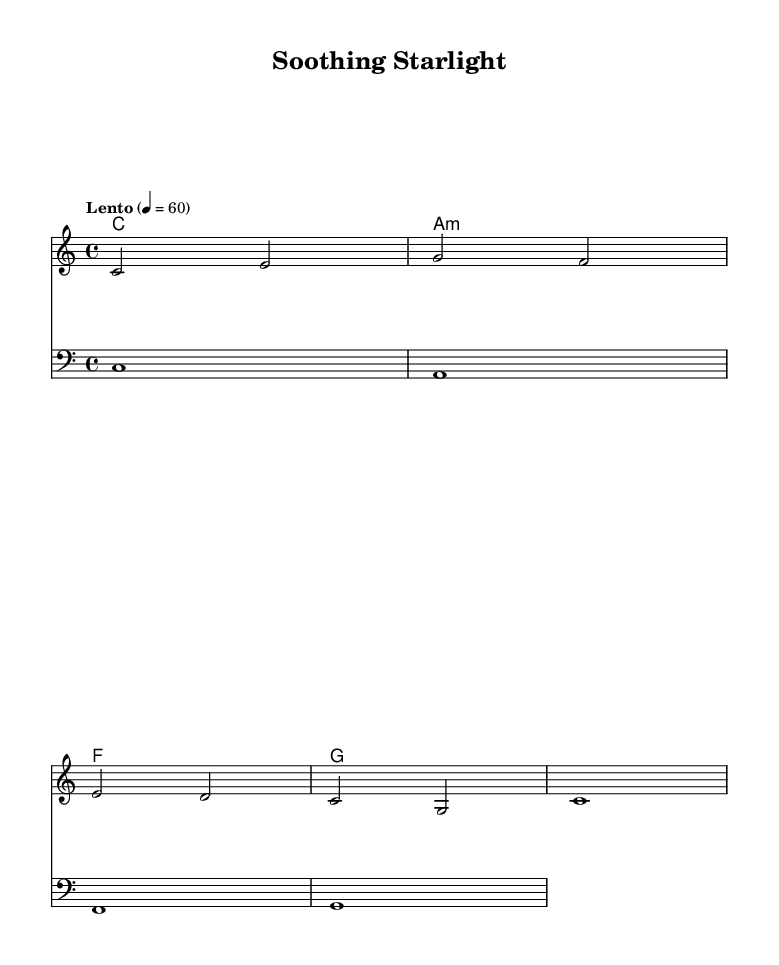What is the key signature of this music? The key signature is C major, which has no sharps or flats.
Answer: C major What is the time signature of the piece? The time signature is indicated at the beginning of the score as 4/4, meaning there are four beats in a measure.
Answer: 4/4 What is the tempo marking? The tempo marking is found written above the staff and it indicates the piece should be played slowly, at a speed of 60 beats per minute.
Answer: Lento How many measures are in the melody? The melody contains four measures, as indicated by the grouping of the notes and rests throughout the snippet.
Answer: 4 What chords are used in the harmony section? The harmony consists of four chords based on the root notes provided in the chord names section: C, A minor, F, and G.
Answer: C, A minor, F, G What is the highest note in the melody? The highest note in the melody is G, which appears early in the first measure.
Answer: G What type of music is "Soothing Starlight"? Given the soft and gentle characteristics along with the electronic essence denoted by the title, it can be classified as electronic lullabies.
Answer: Electronic lullabies 